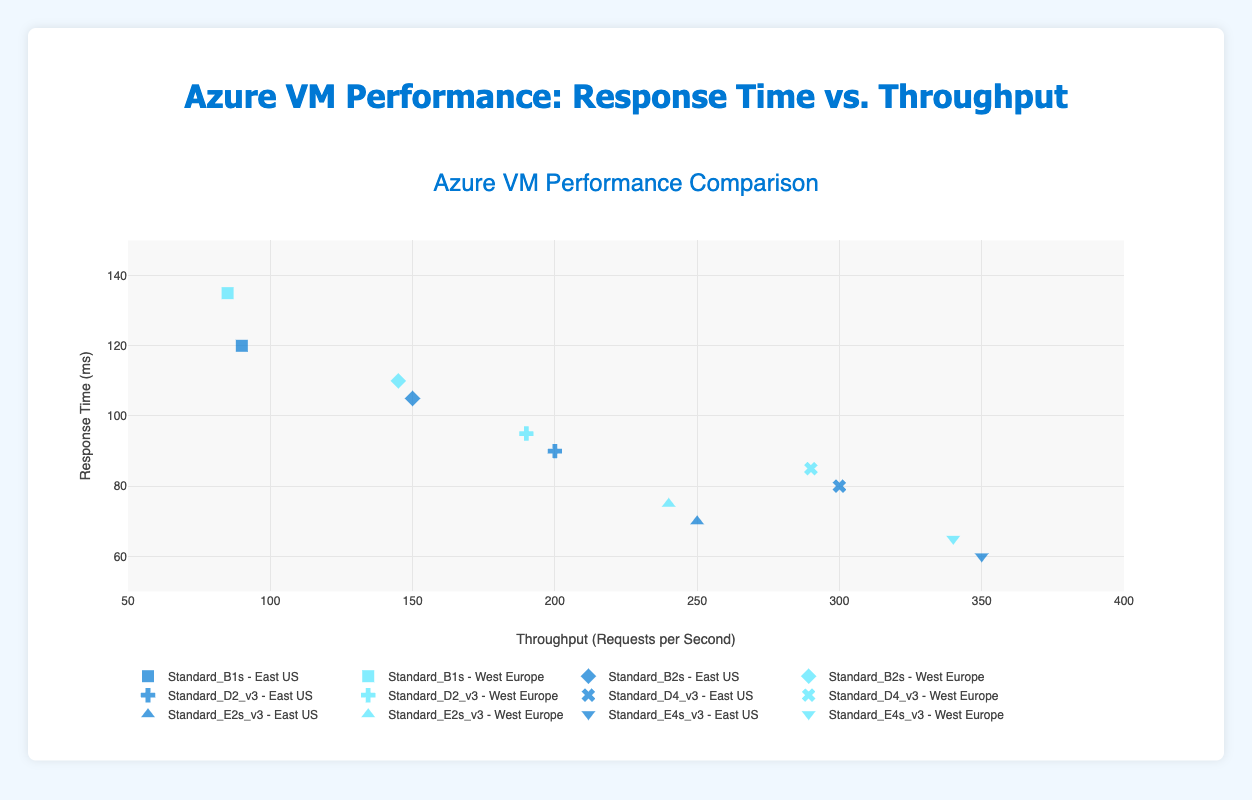What is the title of the figure? The title of the figure is usually displayed at the top of the plot. In this case, it's written out as "Azure VM Performance Comparison".
Answer: Azure VM Performance Comparison How many regions are compared in the figure? The two regions being compared can be identified by the legend, which shows labels for "East US" and "West Europe".
Answer: 2 What is the range of response times for the Standard_D4_v3 VM size? By examining the y-axis locations of the points specifically for the Standard_D4_v3 VM size, we see response times range from the lowest point at 80 ms (East US) to the highest at 85 ms (West Europe).
Answer: 80 ms to 85 ms Which VM size has the highest throughput in East US? To determine the highest throughput, look for the farthest point to the right on the x-axis for East US. The point belongs to the VM size Standard_E4s_v3 with a throughput of 350 requests per second.
Answer: Standard_E4s_v3 Which region shows better performance for the Standard_B2s VM size in terms of response time? Performance comparison can be deduced by comparing the y-axis values of response times for the same VM size across different regions. For Standard_B2s, East US has a better response time of 105 ms compared to West Europe’s 110 ms.
Answer: East US What is the average throughput for the Standard_E2s_v3 VM size across both regions? Average throughput can be calculated by taking the sum of the throughputs in both East US (250 requests per second) and West Europe (240 requests per second) and dividing by 2. (250 + 240) / 2 = 245 requests per second.
Answer: 245 requests per second For the Standard_D2_v3 VM size, which region provides faster response times? By comparing response times on the y-axis, East US has 90 ms and West Europe has 95 ms, so East US provides faster response times.
Answer: East US Is there any VM size that consistently performs better in both regions? Consistent performance can be interpreted by comparing the relative position of points across both regions for each VM size. The Standard_E4s_v3 VM size is close in both response time and throughput across East US (60 ms, 350 requests per second) and West Europe (65 ms, 340 requests per second), indicating consistent performance.
Answer: Standard_E4s_v3 Which region exhibits higher throughput for the Standard_B1s VM size? Throughput comparison is done on the x-axis, with East US having 90 requests per second and West Europe having 85 requests per second, making East US higher.
Answer: East US How does the performance of Standard_D4_v3 in West Europe compare with the best performing VM size in terms of response time? The best performing VM size, Standard_E4s_v3, has response times of 60 ms in East US and 65 ms in West Europe. Standard_D4_v3 in West Europe has a response time of 85 ms which is higher compared to Standard_E4s_v3.
Answer: Standard_D4_v3 has worse response time in West Europe 